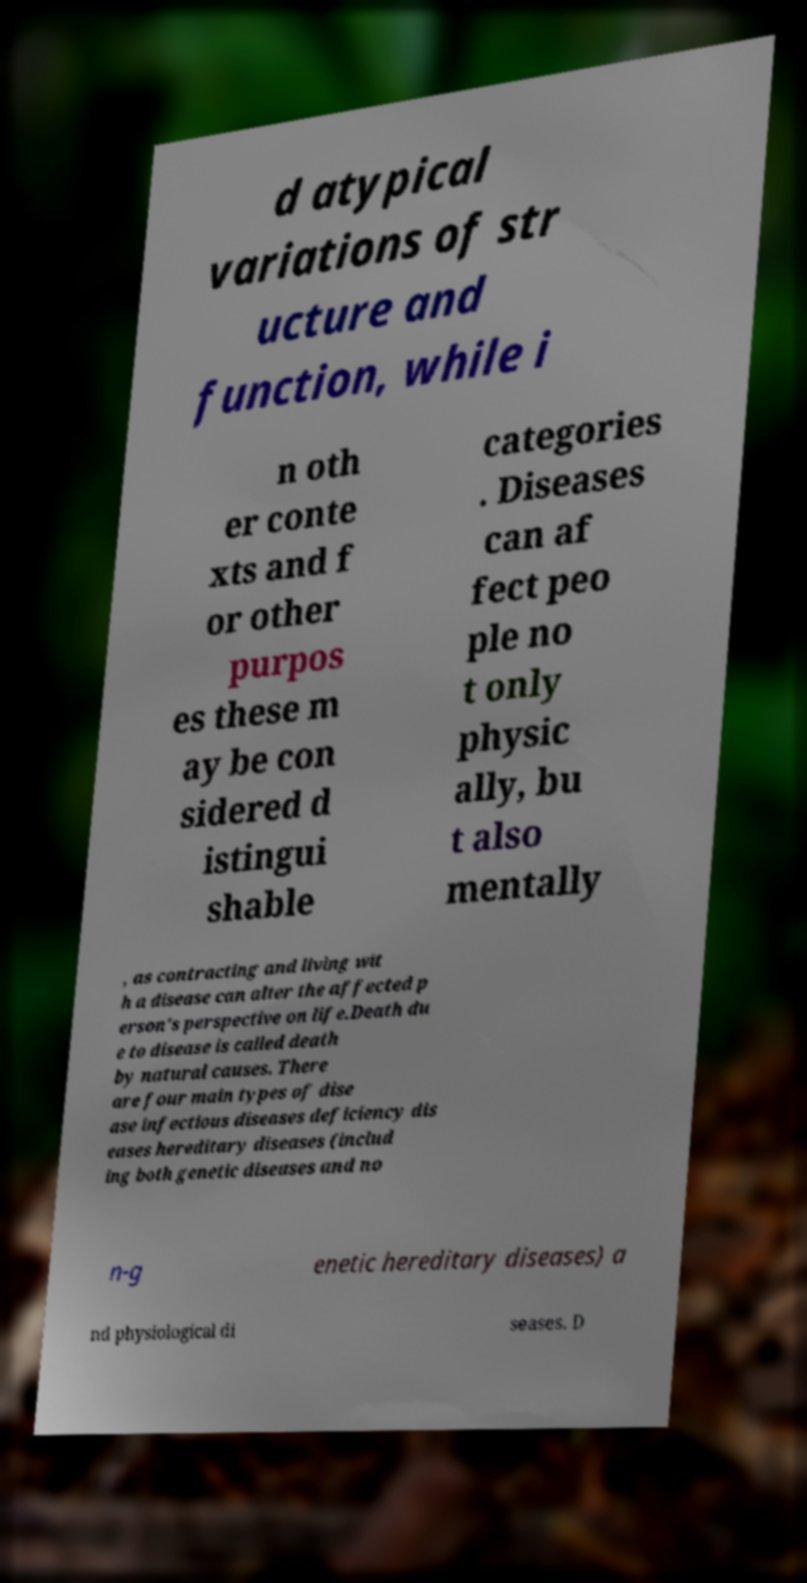There's text embedded in this image that I need extracted. Can you transcribe it verbatim? d atypical variations of str ucture and function, while i n oth er conte xts and f or other purpos es these m ay be con sidered d istingui shable categories . Diseases can af fect peo ple no t only physic ally, bu t also mentally , as contracting and living wit h a disease can alter the affected p erson's perspective on life.Death du e to disease is called death by natural causes. There are four main types of dise ase infectious diseases deficiency dis eases hereditary diseases (includ ing both genetic diseases and no n-g enetic hereditary diseases) a nd physiological di seases. D 